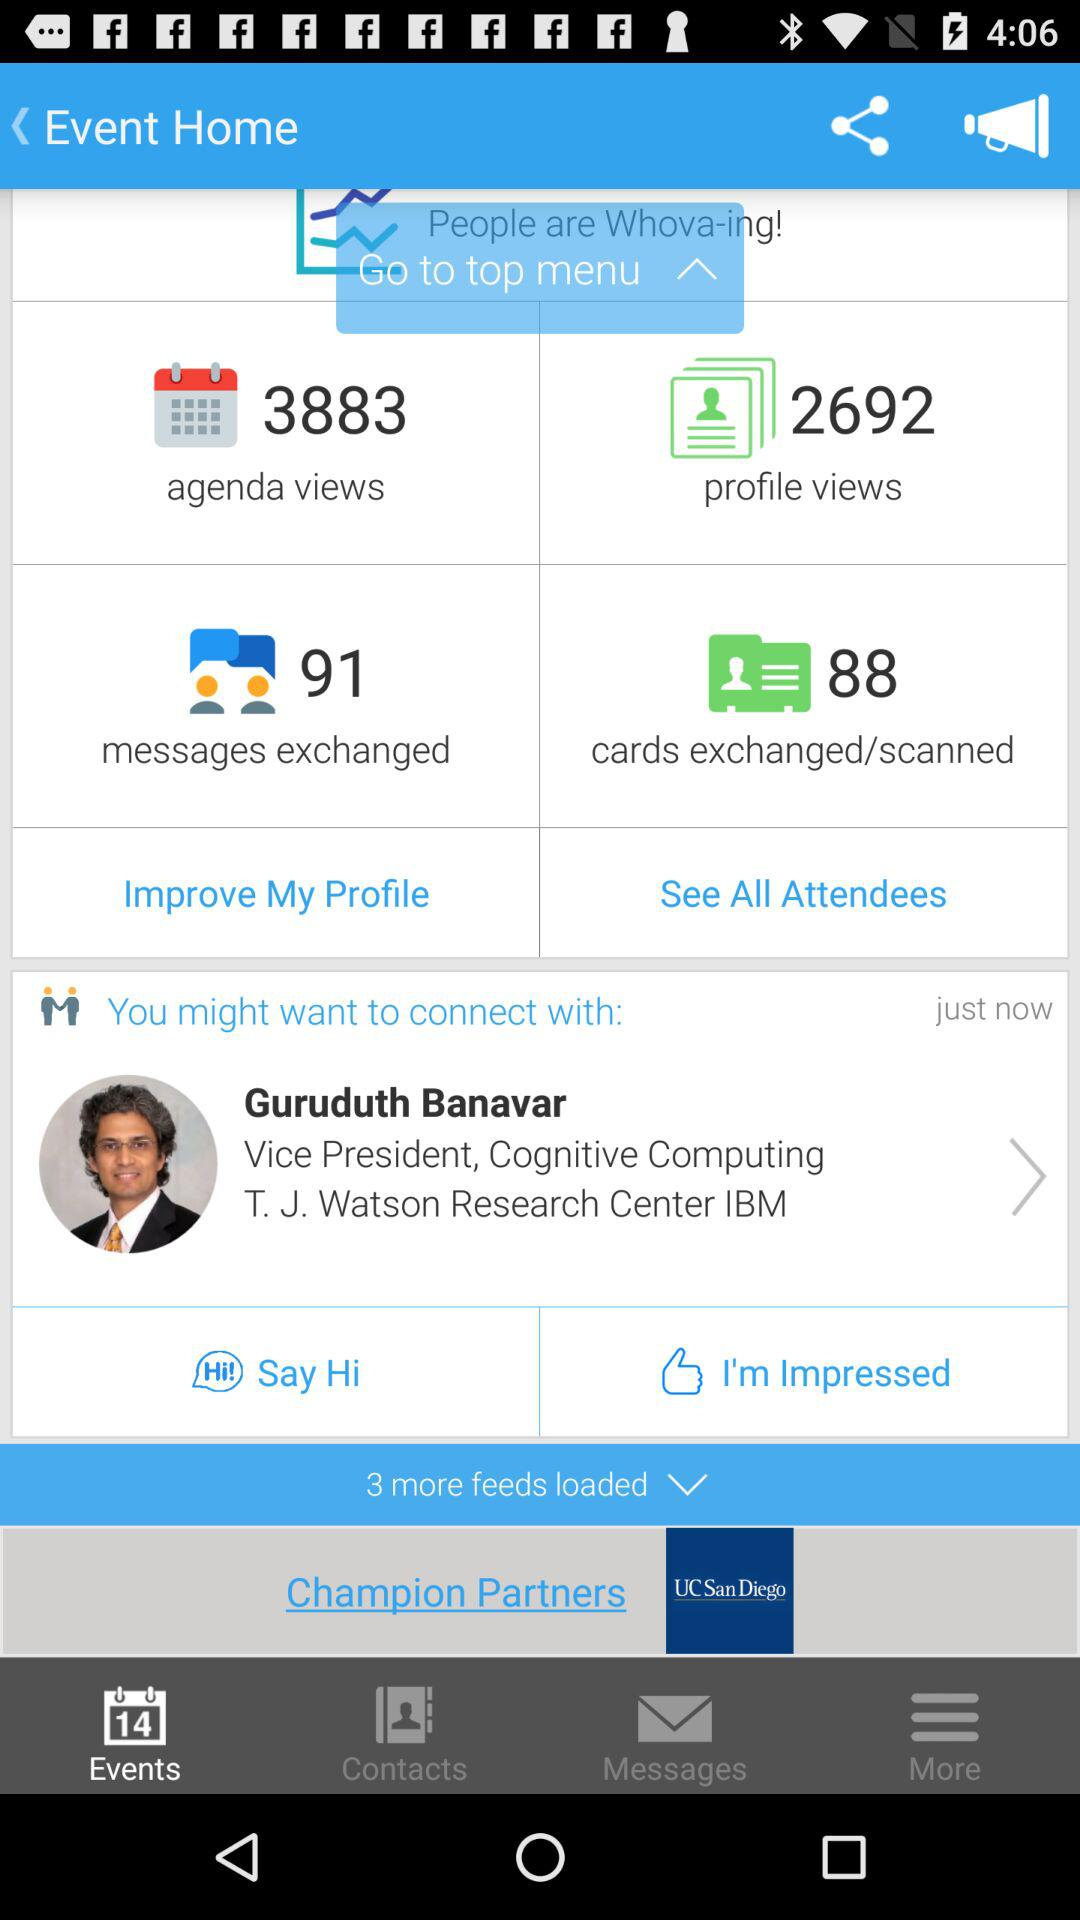How many more agenda views than profile views are there?
Answer the question using a single word or phrase. 1191 